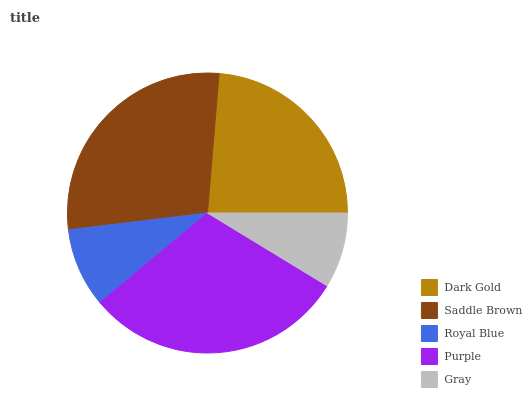Is Gray the minimum?
Answer yes or no. Yes. Is Purple the maximum?
Answer yes or no. Yes. Is Saddle Brown the minimum?
Answer yes or no. No. Is Saddle Brown the maximum?
Answer yes or no. No. Is Saddle Brown greater than Dark Gold?
Answer yes or no. Yes. Is Dark Gold less than Saddle Brown?
Answer yes or no. Yes. Is Dark Gold greater than Saddle Brown?
Answer yes or no. No. Is Saddle Brown less than Dark Gold?
Answer yes or no. No. Is Dark Gold the high median?
Answer yes or no. Yes. Is Dark Gold the low median?
Answer yes or no. Yes. Is Saddle Brown the high median?
Answer yes or no. No. Is Purple the low median?
Answer yes or no. No. 